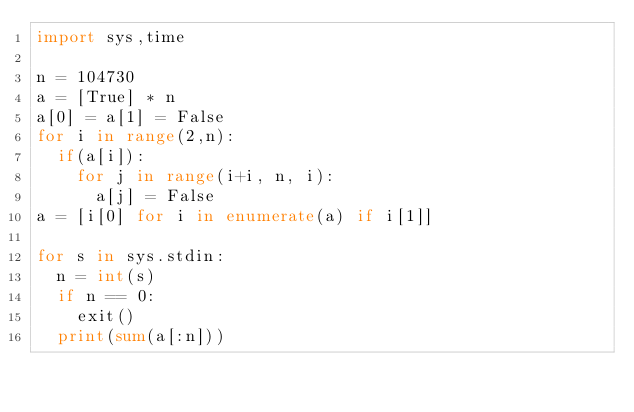<code> <loc_0><loc_0><loc_500><loc_500><_Python_>import sys,time

n = 104730
a = [True] * n
a[0] = a[1] = False
for i in range(2,n):
	if(a[i]):
		for j in range(i+i, n, i):
			a[j] = False
a = [i[0] for i in enumerate(a) if i[1]]

for s in sys.stdin:
	n = int(s)
	if n == 0:
		exit()
	print(sum(a[:n]))</code> 